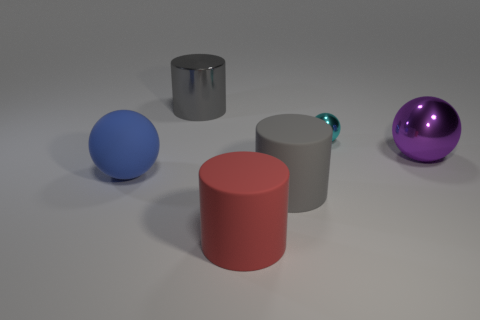Are there more small things than brown blocks?
Make the answer very short. Yes. There is a gray cylinder that is in front of the gray cylinder that is to the left of the gray rubber thing; are there any metal cylinders behind it?
Give a very brief answer. Yes. How many other objects are the same size as the red thing?
Ensure brevity in your answer.  4. There is a large purple object; are there any gray shiny objects in front of it?
Offer a terse response. No. Is the color of the large metal cylinder the same as the object right of the small thing?
Offer a terse response. No. The large cylinder in front of the large gray object in front of the large gray cylinder to the left of the red object is what color?
Keep it short and to the point. Red. Is there a blue metal object that has the same shape as the blue rubber thing?
Provide a succinct answer. No. What color is the matte sphere that is the same size as the metallic cylinder?
Offer a terse response. Blue. What is the object that is behind the tiny cyan object made of?
Provide a succinct answer. Metal. Does the large shiny thing that is on the left side of the small metal sphere have the same shape as the matte object behind the gray rubber cylinder?
Your answer should be compact. No. 